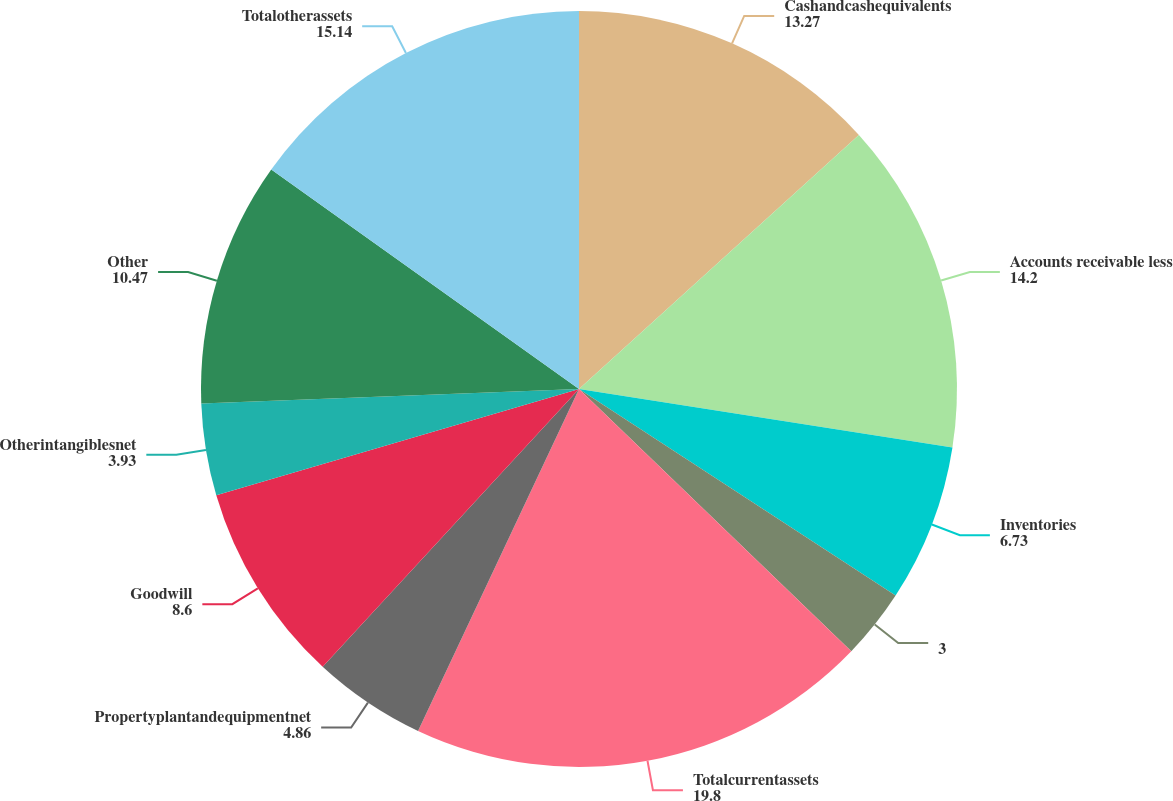Convert chart to OTSL. <chart><loc_0><loc_0><loc_500><loc_500><pie_chart><fcel>Cashandcashequivalents<fcel>Accounts receivable less<fcel>Inventories<fcel>Unnamed: 3<fcel>Totalcurrentassets<fcel>Propertyplantandequipmentnet<fcel>Goodwill<fcel>Otherintangiblesnet<fcel>Other<fcel>Totalotherassets<nl><fcel>13.27%<fcel>14.2%<fcel>6.73%<fcel>3.0%<fcel>19.8%<fcel>4.86%<fcel>8.6%<fcel>3.93%<fcel>10.47%<fcel>15.14%<nl></chart> 